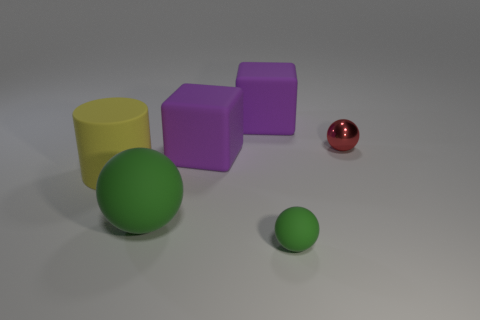Add 1 big green matte spheres. How many objects exist? 7 Subtract all cylinders. How many objects are left? 5 Add 6 red blocks. How many red blocks exist? 6 Subtract 0 red cylinders. How many objects are left? 6 Subtract all big yellow matte things. Subtract all big yellow shiny objects. How many objects are left? 5 Add 3 big green objects. How many big green objects are left? 4 